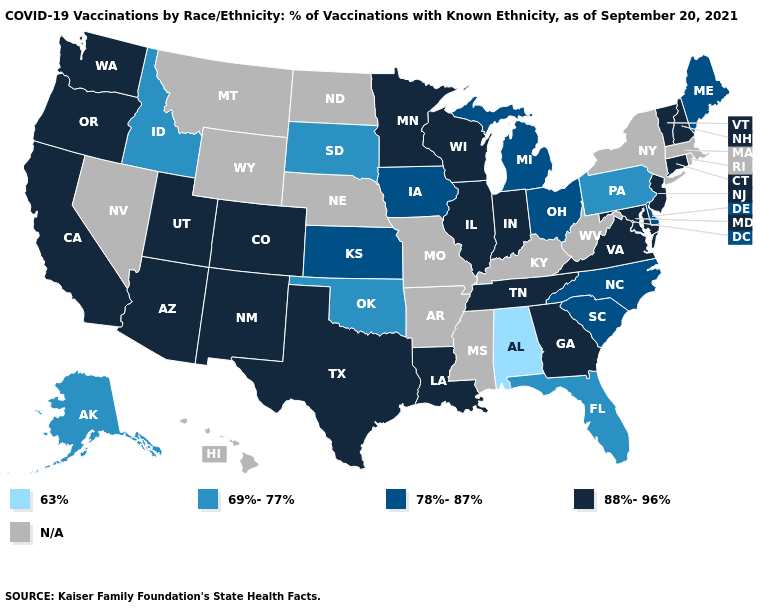Which states have the highest value in the USA?
Keep it brief. Arizona, California, Colorado, Connecticut, Georgia, Illinois, Indiana, Louisiana, Maryland, Minnesota, New Hampshire, New Jersey, New Mexico, Oregon, Tennessee, Texas, Utah, Vermont, Virginia, Washington, Wisconsin. Which states have the lowest value in the USA?
Concise answer only. Alabama. What is the value of Mississippi?
Quick response, please. N/A. What is the highest value in the MidWest ?
Quick response, please. 88%-96%. Among the states that border Alabama , which have the lowest value?
Answer briefly. Florida. Does the map have missing data?
Keep it brief. Yes. Does New Hampshire have the highest value in the USA?
Keep it brief. Yes. Name the states that have a value in the range 63%?
Short answer required. Alabama. Which states have the lowest value in the MidWest?
Concise answer only. South Dakota. Does Idaho have the highest value in the West?
Give a very brief answer. No. 